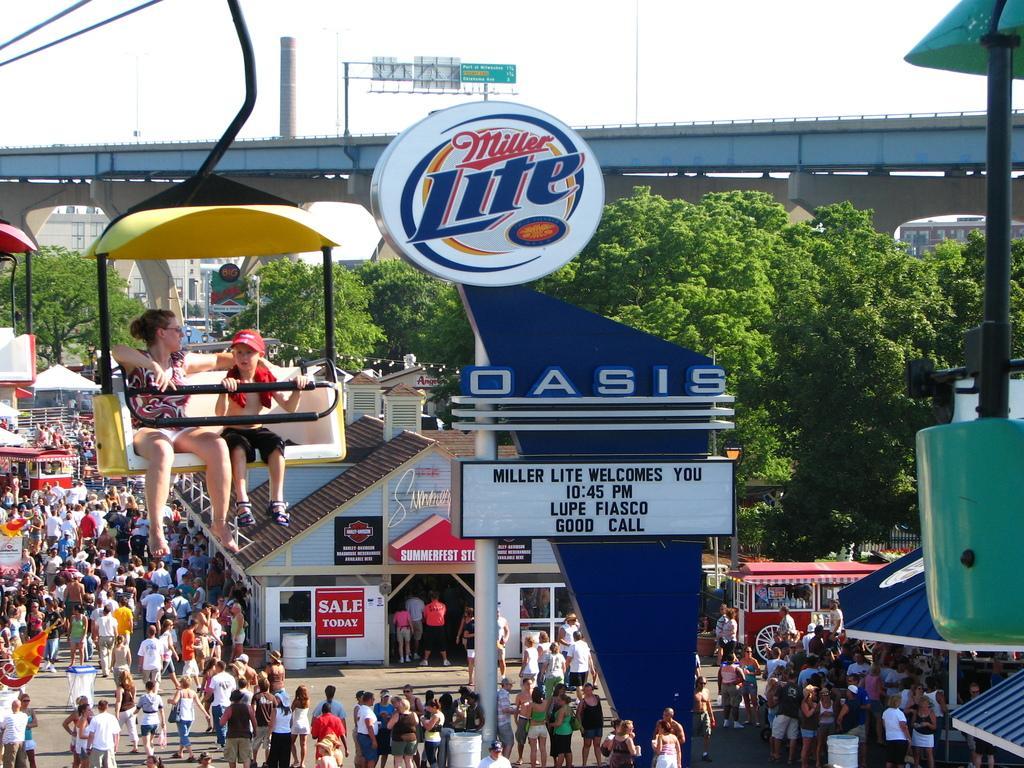In one or two sentences, can you explain what this image depicts? The image is taken outside a city. In the foreground of the picture there are board, cable car, people and other objects. At the bottom there are people walking on the road and there are buildings, vehicles and other objects. In the center of the picture there are trees, people and other objects. In the background there is bridge and railing. 